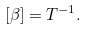Convert formula to latex. <formula><loc_0><loc_0><loc_500><loc_500>[ \beta ] = T ^ { - 1 } .</formula> 